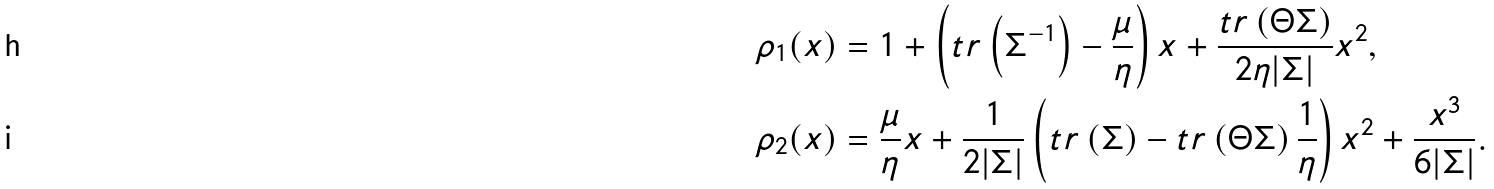<formula> <loc_0><loc_0><loc_500><loc_500>\rho _ { 1 } ( x ) & = 1 + \left ( t r \left ( \Sigma ^ { - 1 } \right ) - \frac { \mu } { \eta } \right ) x + \frac { t r \left ( \Theta \Sigma \right ) } { 2 \eta | \Sigma | } x ^ { 2 } , \\ \rho _ { 2 } ( x ) & = \frac { \mu } { \eta } x + \frac { 1 } { 2 | \Sigma | } \left ( t r \left ( \Sigma \right ) - t r \left ( \Theta \Sigma \right ) \frac { 1 } { \eta } \right ) x ^ { 2 } + \frac { x ^ { 3 } } { 6 | \Sigma | } .</formula> 